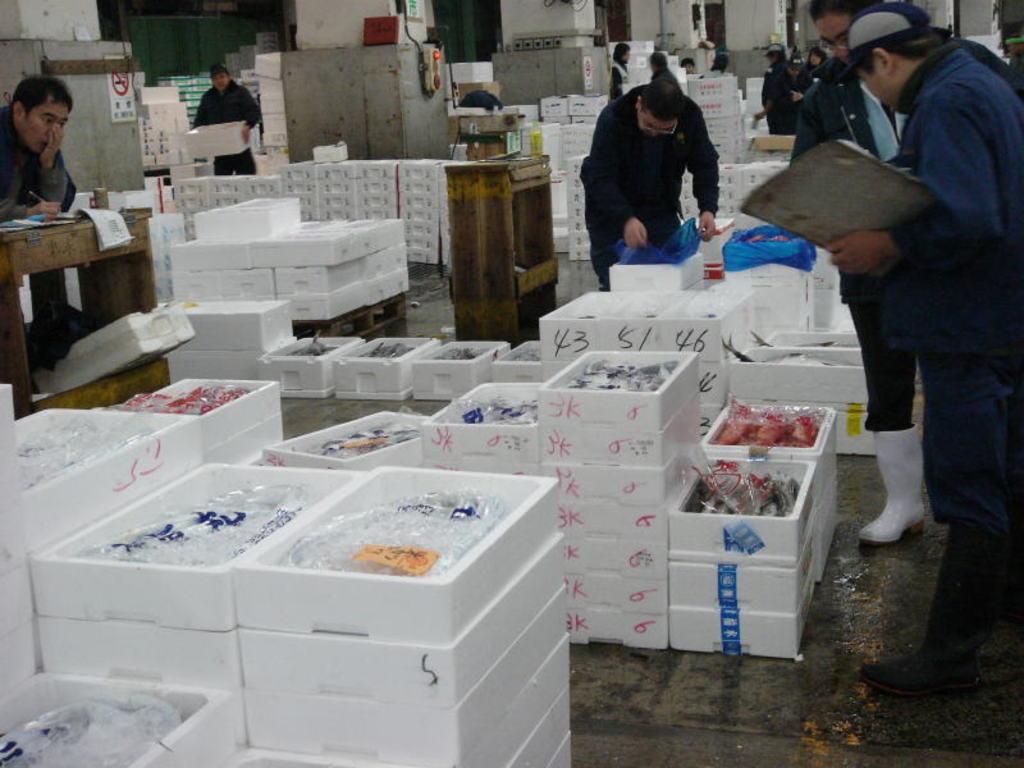Please provide a concise description of this image. In this image there are group of people standing, there is a person sitting, there are some objects on the tables, there are sign boards to the pillars , there are so many items in the boxes. 